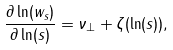<formula> <loc_0><loc_0><loc_500><loc_500>\frac { \partial \ln ( w _ { s } ) } { \partial \ln ( s ) } = \nu _ { \perp } + \zeta ( \ln ( s ) ) ,</formula> 